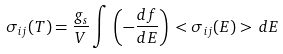Convert formula to latex. <formula><loc_0><loc_0><loc_500><loc_500>\sigma _ { i j } ( T ) = \frac { g _ { s } } { V } \int \, \left ( - \frac { d f } { d E } \right ) \, < \sigma _ { i j } ( E ) > \, d E</formula> 